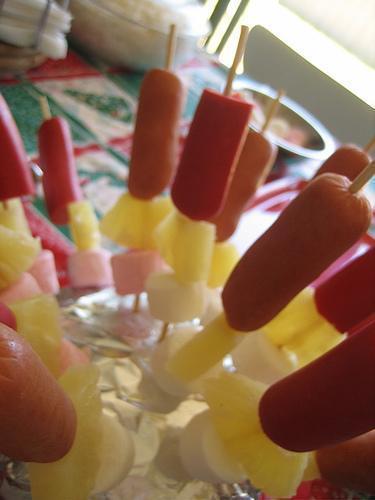How many hot dogs can be seen?
Give a very brief answer. 9. How many bananas are there?
Give a very brief answer. 3. How many people are wearing yellow shirt?
Give a very brief answer. 0. 